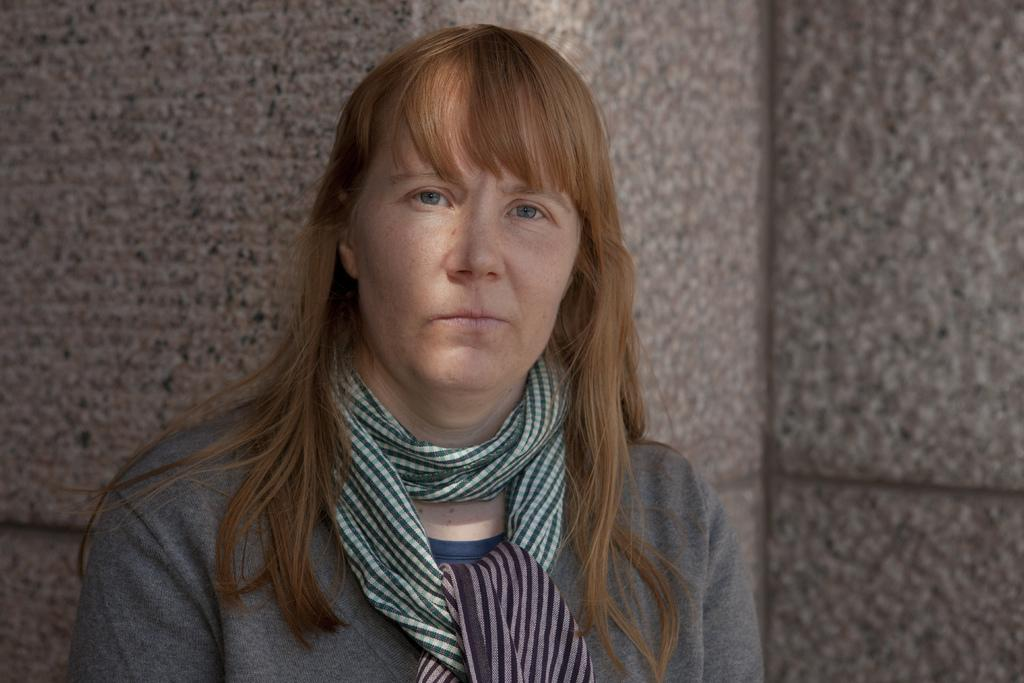Who is present in the image? There is a woman in the image. What is the woman wearing in the image? The woman is wearing a scarf in the image. What can be seen in the background of the image? There is a well in the background of the image. How many pigs are visible in the image? There are no pigs present in the image. What type of adjustment is the woman making to her heart in the image? There is no indication in the image that the woman is making any adjustments to her heart. 